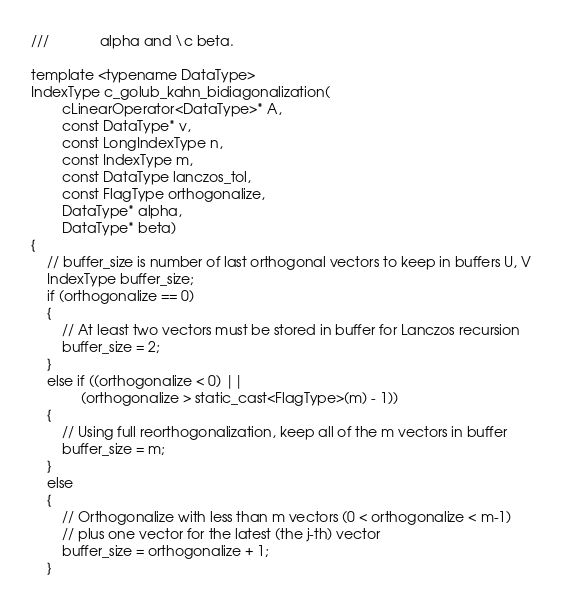<code> <loc_0><loc_0><loc_500><loc_500><_C++_>///             alpha and \c beta.

template <typename DataType>
IndexType c_golub_kahn_bidiagonalization(
        cLinearOperator<DataType>* A,
        const DataType* v,
        const LongIndexType n,
        const IndexType m,
        const DataType lanczos_tol,
        const FlagType orthogonalize,
        DataType* alpha,
        DataType* beta)
{
    // buffer_size is number of last orthogonal vectors to keep in buffers U, V
    IndexType buffer_size;
    if (orthogonalize == 0)
    {
        // At least two vectors must be stored in buffer for Lanczos recursion
        buffer_size = 2;
    }
    else if ((orthogonalize < 0) ||
             (orthogonalize > static_cast<FlagType>(m) - 1))
    {
        // Using full reorthogonalization, keep all of the m vectors in buffer
        buffer_size = m;
    }
    else
    {
        // Orthogonalize with less than m vectors (0 < orthogonalize < m-1)
        // plus one vector for the latest (the j-th) vector
        buffer_size = orthogonalize + 1;
    }
</code> 